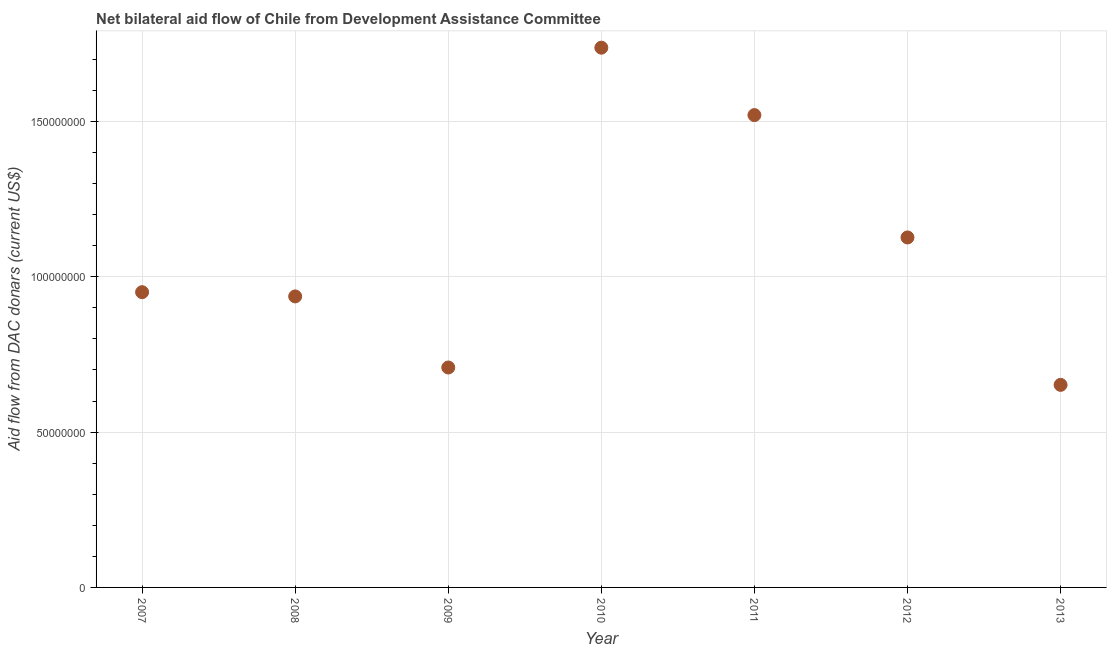What is the net bilateral aid flows from dac donors in 2008?
Your response must be concise. 9.37e+07. Across all years, what is the maximum net bilateral aid flows from dac donors?
Ensure brevity in your answer.  1.74e+08. Across all years, what is the minimum net bilateral aid flows from dac donors?
Make the answer very short. 6.52e+07. In which year was the net bilateral aid flows from dac donors minimum?
Ensure brevity in your answer.  2013. What is the sum of the net bilateral aid flows from dac donors?
Your answer should be compact. 7.63e+08. What is the difference between the net bilateral aid flows from dac donors in 2007 and 2013?
Your answer should be compact. 2.98e+07. What is the average net bilateral aid flows from dac donors per year?
Your answer should be very brief. 1.09e+08. What is the median net bilateral aid flows from dac donors?
Ensure brevity in your answer.  9.50e+07. In how many years, is the net bilateral aid flows from dac donors greater than 150000000 US$?
Make the answer very short. 2. What is the ratio of the net bilateral aid flows from dac donors in 2009 to that in 2012?
Your answer should be very brief. 0.63. Is the difference between the net bilateral aid flows from dac donors in 2011 and 2013 greater than the difference between any two years?
Ensure brevity in your answer.  No. What is the difference between the highest and the second highest net bilateral aid flows from dac donors?
Provide a succinct answer. 2.17e+07. What is the difference between the highest and the lowest net bilateral aid flows from dac donors?
Keep it short and to the point. 1.09e+08. Does the net bilateral aid flows from dac donors monotonically increase over the years?
Provide a short and direct response. No. Are the values on the major ticks of Y-axis written in scientific E-notation?
Provide a short and direct response. No. What is the title of the graph?
Offer a terse response. Net bilateral aid flow of Chile from Development Assistance Committee. What is the label or title of the Y-axis?
Your response must be concise. Aid flow from DAC donars (current US$). What is the Aid flow from DAC donars (current US$) in 2007?
Make the answer very short. 9.50e+07. What is the Aid flow from DAC donars (current US$) in 2008?
Your answer should be compact. 9.37e+07. What is the Aid flow from DAC donars (current US$) in 2009?
Provide a succinct answer. 7.08e+07. What is the Aid flow from DAC donars (current US$) in 2010?
Your response must be concise. 1.74e+08. What is the Aid flow from DAC donars (current US$) in 2011?
Your response must be concise. 1.52e+08. What is the Aid flow from DAC donars (current US$) in 2012?
Give a very brief answer. 1.13e+08. What is the Aid flow from DAC donars (current US$) in 2013?
Make the answer very short. 6.52e+07. What is the difference between the Aid flow from DAC donars (current US$) in 2007 and 2008?
Give a very brief answer. 1.36e+06. What is the difference between the Aid flow from DAC donars (current US$) in 2007 and 2009?
Offer a very short reply. 2.42e+07. What is the difference between the Aid flow from DAC donars (current US$) in 2007 and 2010?
Make the answer very short. -7.87e+07. What is the difference between the Aid flow from DAC donars (current US$) in 2007 and 2011?
Your answer should be very brief. -5.70e+07. What is the difference between the Aid flow from DAC donars (current US$) in 2007 and 2012?
Give a very brief answer. -1.76e+07. What is the difference between the Aid flow from DAC donars (current US$) in 2007 and 2013?
Your answer should be very brief. 2.98e+07. What is the difference between the Aid flow from DAC donars (current US$) in 2008 and 2009?
Your answer should be very brief. 2.29e+07. What is the difference between the Aid flow from DAC donars (current US$) in 2008 and 2010?
Make the answer very short. -8.01e+07. What is the difference between the Aid flow from DAC donars (current US$) in 2008 and 2011?
Your response must be concise. -5.84e+07. What is the difference between the Aid flow from DAC donars (current US$) in 2008 and 2012?
Provide a succinct answer. -1.90e+07. What is the difference between the Aid flow from DAC donars (current US$) in 2008 and 2013?
Your answer should be very brief. 2.85e+07. What is the difference between the Aid flow from DAC donars (current US$) in 2009 and 2010?
Give a very brief answer. -1.03e+08. What is the difference between the Aid flow from DAC donars (current US$) in 2009 and 2011?
Your answer should be very brief. -8.13e+07. What is the difference between the Aid flow from DAC donars (current US$) in 2009 and 2012?
Make the answer very short. -4.19e+07. What is the difference between the Aid flow from DAC donars (current US$) in 2009 and 2013?
Your answer should be compact. 5.59e+06. What is the difference between the Aid flow from DAC donars (current US$) in 2010 and 2011?
Provide a succinct answer. 2.17e+07. What is the difference between the Aid flow from DAC donars (current US$) in 2010 and 2012?
Offer a very short reply. 6.11e+07. What is the difference between the Aid flow from DAC donars (current US$) in 2010 and 2013?
Provide a succinct answer. 1.09e+08. What is the difference between the Aid flow from DAC donars (current US$) in 2011 and 2012?
Offer a terse response. 3.94e+07. What is the difference between the Aid flow from DAC donars (current US$) in 2011 and 2013?
Ensure brevity in your answer.  8.68e+07. What is the difference between the Aid flow from DAC donars (current US$) in 2012 and 2013?
Provide a short and direct response. 4.75e+07. What is the ratio of the Aid flow from DAC donars (current US$) in 2007 to that in 2009?
Your answer should be very brief. 1.34. What is the ratio of the Aid flow from DAC donars (current US$) in 2007 to that in 2010?
Your answer should be very brief. 0.55. What is the ratio of the Aid flow from DAC donars (current US$) in 2007 to that in 2011?
Provide a short and direct response. 0.62. What is the ratio of the Aid flow from DAC donars (current US$) in 2007 to that in 2012?
Ensure brevity in your answer.  0.84. What is the ratio of the Aid flow from DAC donars (current US$) in 2007 to that in 2013?
Ensure brevity in your answer.  1.46. What is the ratio of the Aid flow from DAC donars (current US$) in 2008 to that in 2009?
Keep it short and to the point. 1.32. What is the ratio of the Aid flow from DAC donars (current US$) in 2008 to that in 2010?
Your response must be concise. 0.54. What is the ratio of the Aid flow from DAC donars (current US$) in 2008 to that in 2011?
Your response must be concise. 0.62. What is the ratio of the Aid flow from DAC donars (current US$) in 2008 to that in 2012?
Your answer should be compact. 0.83. What is the ratio of the Aid flow from DAC donars (current US$) in 2008 to that in 2013?
Offer a terse response. 1.44. What is the ratio of the Aid flow from DAC donars (current US$) in 2009 to that in 2010?
Your answer should be compact. 0.41. What is the ratio of the Aid flow from DAC donars (current US$) in 2009 to that in 2011?
Ensure brevity in your answer.  0.47. What is the ratio of the Aid flow from DAC donars (current US$) in 2009 to that in 2012?
Offer a terse response. 0.63. What is the ratio of the Aid flow from DAC donars (current US$) in 2009 to that in 2013?
Give a very brief answer. 1.09. What is the ratio of the Aid flow from DAC donars (current US$) in 2010 to that in 2011?
Keep it short and to the point. 1.14. What is the ratio of the Aid flow from DAC donars (current US$) in 2010 to that in 2012?
Ensure brevity in your answer.  1.54. What is the ratio of the Aid flow from DAC donars (current US$) in 2010 to that in 2013?
Give a very brief answer. 2.67. What is the ratio of the Aid flow from DAC donars (current US$) in 2011 to that in 2012?
Keep it short and to the point. 1.35. What is the ratio of the Aid flow from DAC donars (current US$) in 2011 to that in 2013?
Give a very brief answer. 2.33. What is the ratio of the Aid flow from DAC donars (current US$) in 2012 to that in 2013?
Ensure brevity in your answer.  1.73. 